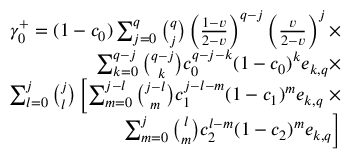<formula> <loc_0><loc_0><loc_500><loc_500>\begin{array} { r } { \gamma _ { 0 } ^ { + } = ( 1 - c _ { 0 } ) \sum _ { j = 0 } ^ { q } { \binom { q } { j } } \left ( \frac { 1 - v } { 2 - v } \right ) ^ { q - j } \left ( \frac { v } { 2 - v } \right ) ^ { j } \times } \\ { \sum _ { k = 0 } ^ { q - j } { \binom { q - j } { k } } c _ { 0 } ^ { q - j - k } ( 1 - c _ { 0 } ) ^ { k } e _ { k , q } \times } \\ { \sum _ { l = 0 } ^ { j } { \binom { j } { l } } \left [ \sum _ { m = 0 } ^ { j - l } { \binom { j - l } { m } } c _ { 1 } ^ { j - l - m } ( 1 - c _ { 1 } ) ^ { m } e _ { k , q } \times } \\ { \sum _ { m = 0 } ^ { j } { \binom { l } { m } } c _ { 2 } ^ { l - m } ( 1 - c _ { 2 } ) ^ { m } e _ { k , q } \right ] } \end{array}</formula> 